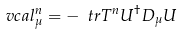Convert formula to latex. <formula><loc_0><loc_0><loc_500><loc_500>\ v c a l _ { \mu } ^ { n } = - \ t r T ^ { n } U ^ { \dagger } D _ { \mu } U</formula> 